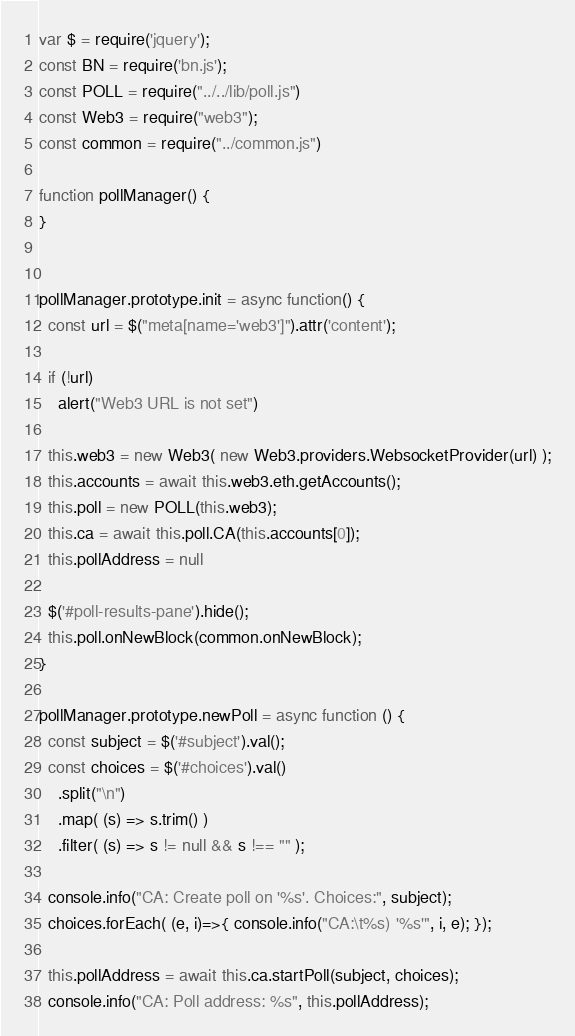<code> <loc_0><loc_0><loc_500><loc_500><_JavaScript_>
var $ = require('jquery');
const BN = require('bn.js');
const POLL = require("../../lib/poll.js")
const Web3 = require("web3");
const common = require("../common.js")

function pollManager() {
}


pollManager.prototype.init = async function() {
  const url = $("meta[name='web3']").attr('content');

  if (!url)
    alert("Web3 URL is not set")

  this.web3 = new Web3( new Web3.providers.WebsocketProvider(url) );
  this.accounts = await this.web3.eth.getAccounts();
  this.poll = new POLL(this.web3);
  this.ca = await this.poll.CA(this.accounts[0]);
  this.pollAddress = null

  $('#poll-results-pane').hide();
  this.poll.onNewBlock(common.onNewBlock);
}

pollManager.prototype.newPoll = async function () {
  const subject = $('#subject').val();
  const choices = $('#choices').val()
    .split("\n")
    .map( (s) => s.trim() )
    .filter( (s) => s != null && s !== "" );

  console.info("CA: Create poll on '%s'. Choices:", subject);
  choices.forEach( (e, i)=>{ console.info("CA:\t%s) '%s'", i, e); });

  this.pollAddress = await this.ca.startPoll(subject, choices);
  console.info("CA: Poll address: %s", this.pollAddress);
</code> 